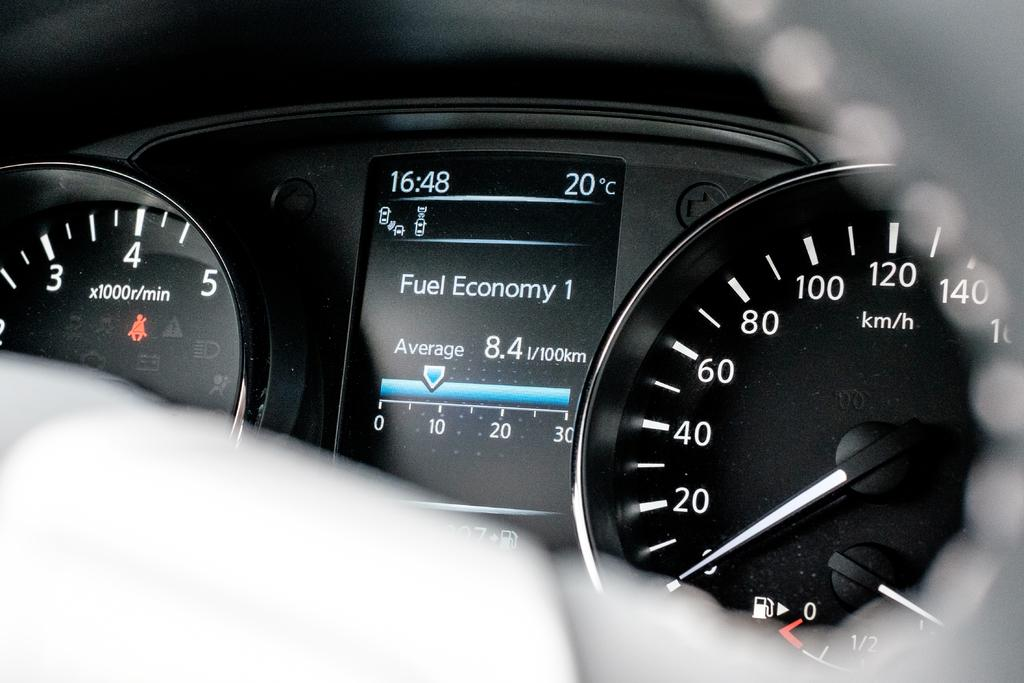What is the main subject of the image? The main subject of the image is a vehicle's speedometer. Can you describe the condition of the image? The top and bottom of the image are blurry. What type of fork can be seen in the image? There is no fork present in the image; it features a vehicle's speedometer. How does the spark interact with the speedometer in the image? There is no spark present in the image; it only shows a vehicle's speedometer. 